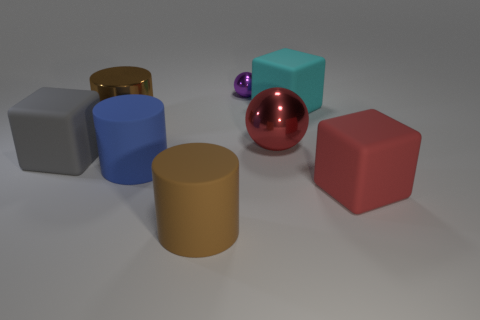Subtract all blue blocks. Subtract all blue balls. How many blocks are left? 3 Add 1 purple cylinders. How many objects exist? 9 Subtract all cylinders. How many objects are left? 5 Subtract all tiny brown metallic things. Subtract all big red objects. How many objects are left? 6 Add 8 large gray matte objects. How many large gray matte objects are left? 9 Add 4 brown metal cylinders. How many brown metal cylinders exist? 5 Subtract 1 blue cylinders. How many objects are left? 7 